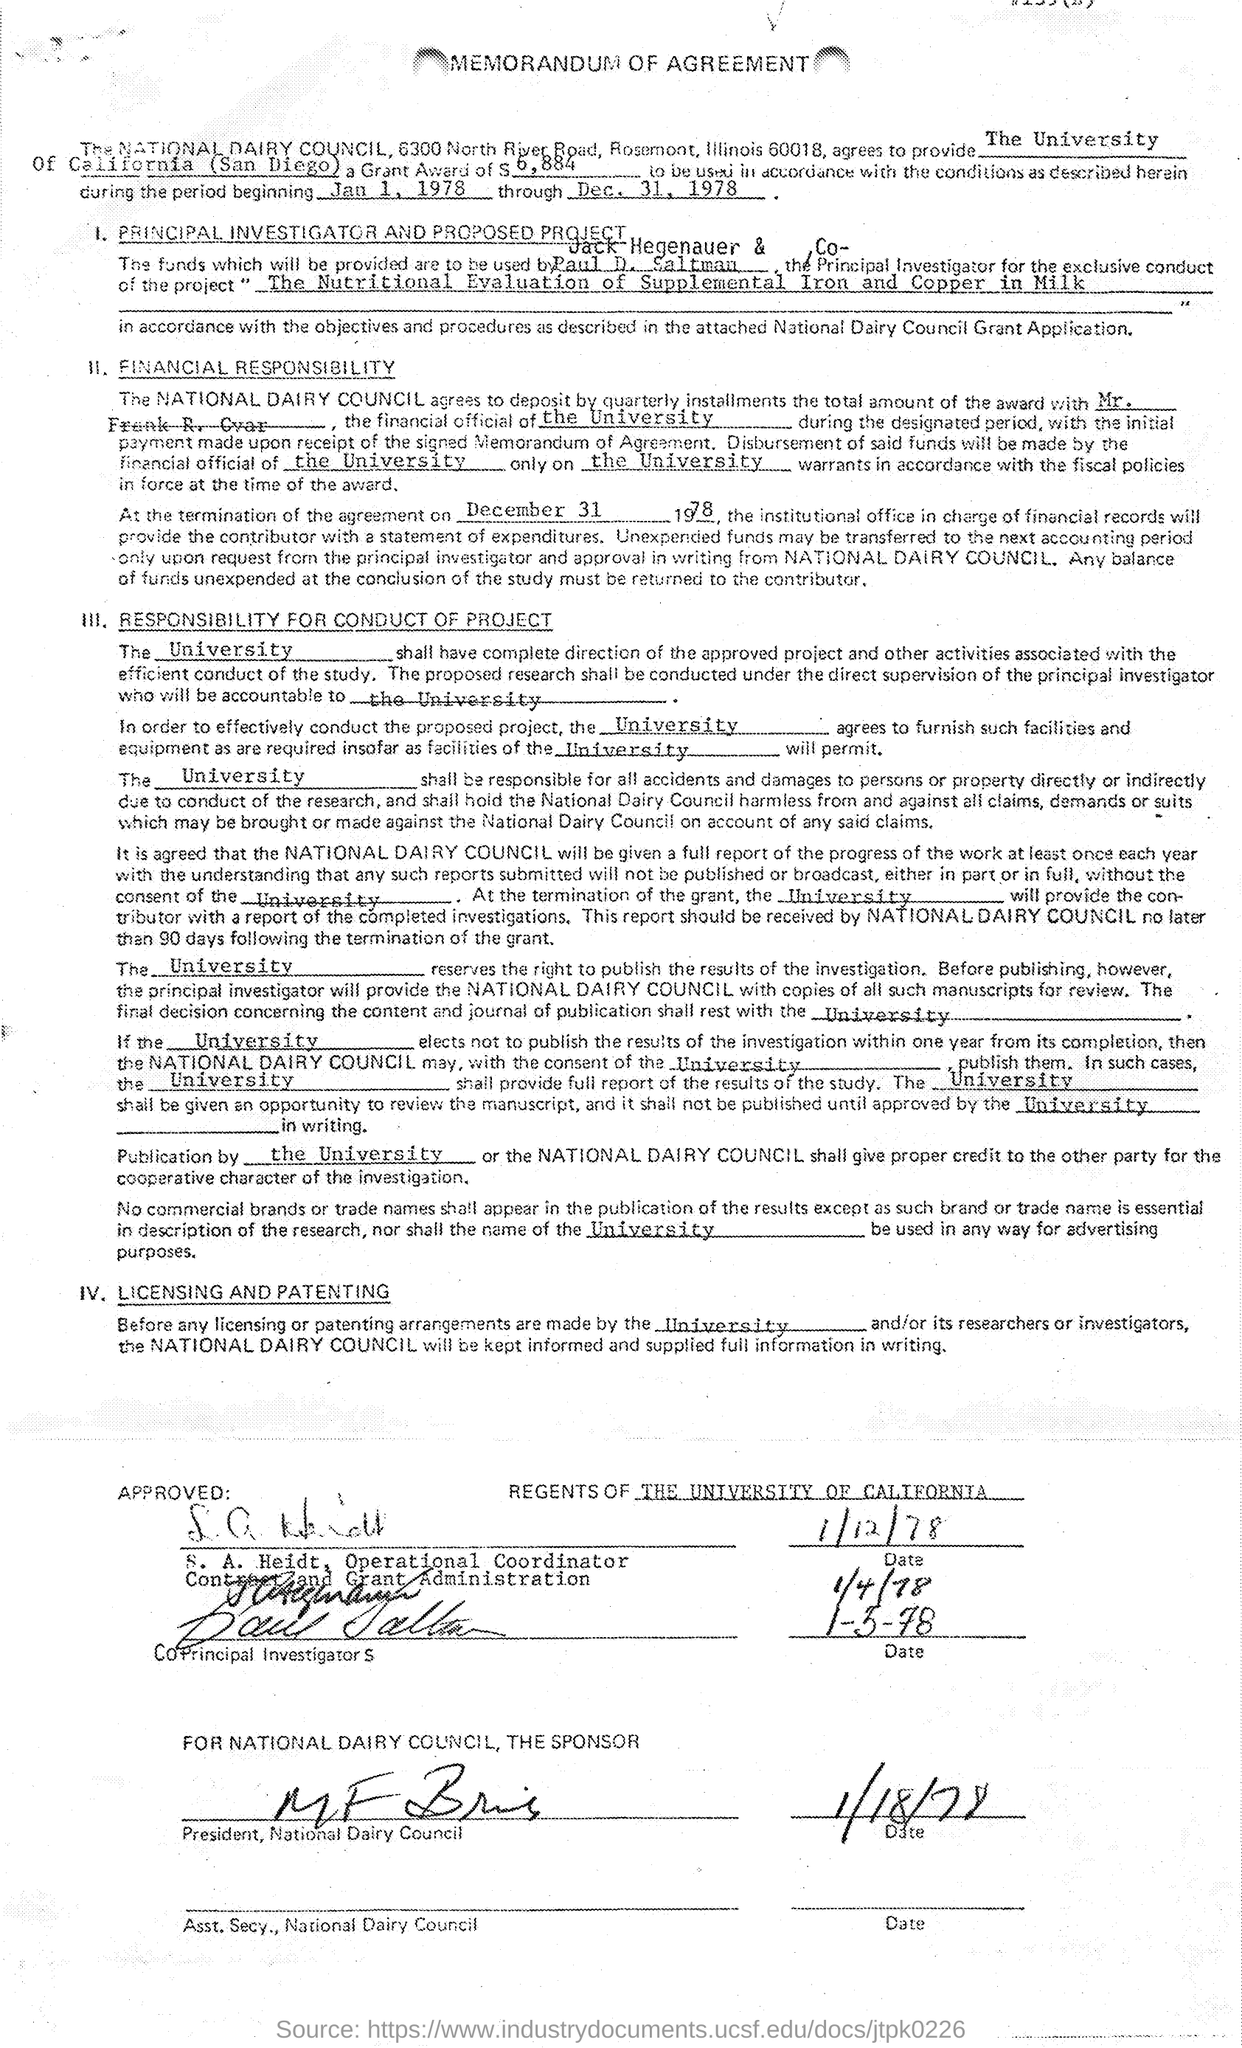What is the name of the university mentioned in the memorandum of agreement ?
Ensure brevity in your answer.  The university of california (san diego). What is the amount of grant award mentioned in the given agreement ?
Your answer should be compact. 6,884. What is the date of termination of the agreement as mentioned in the agreement ?
Offer a terse response. December 31 1978. What is the project mentioned in the given agreement ?
Make the answer very short. "The nutritional evaluation of supplemental iron and copper in milk. 